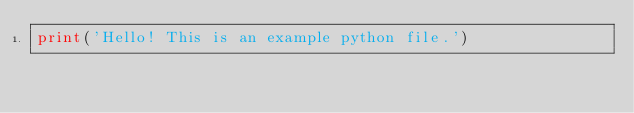<code> <loc_0><loc_0><loc_500><loc_500><_Python_>print('Hello! This is an example python file.')</code> 